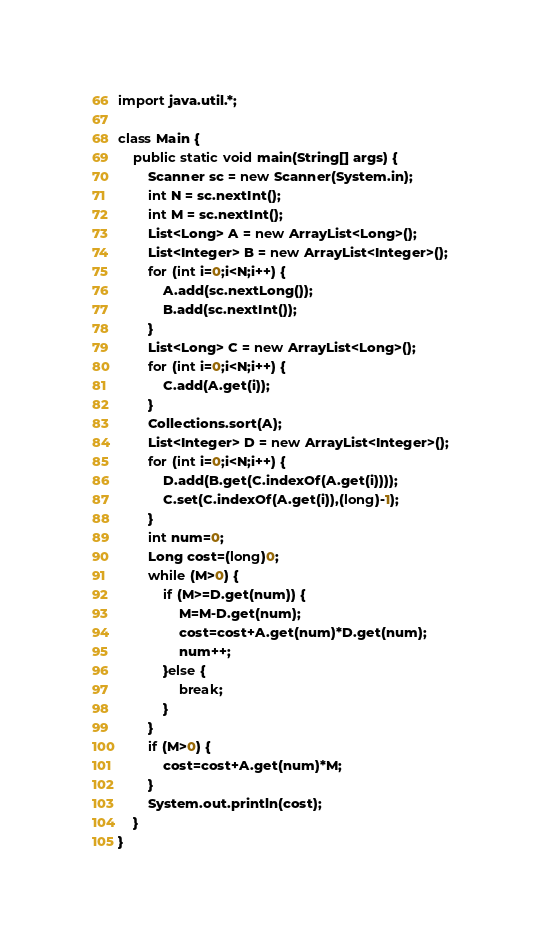Convert code to text. <code><loc_0><loc_0><loc_500><loc_500><_Java_>import java.util.*;

class Main {
	public static void main(String[] args) {
		Scanner sc = new Scanner(System.in);
		int N = sc.nextInt();
		int M = sc.nextInt();
		List<Long> A = new ArrayList<Long>();
		List<Integer> B = new ArrayList<Integer>();
		for (int i=0;i<N;i++) {
			A.add(sc.nextLong());
			B.add(sc.nextInt());
		}
		List<Long> C = new ArrayList<Long>();
		for (int i=0;i<N;i++) {
			C.add(A.get(i));
		}
		Collections.sort(A);
		List<Integer> D = new ArrayList<Integer>();
		for (int i=0;i<N;i++) {
			D.add(B.get(C.indexOf(A.get(i))));
			C.set(C.indexOf(A.get(i)),(long)-1);
		}
		int num=0;
		Long cost=(long)0;
		while (M>0) {
			if (M>=D.get(num)) {
				M=M-D.get(num);
				cost=cost+A.get(num)*D.get(num);
				num++;
			}else {
				break;
			}
		}
		if (M>0) {
			cost=cost+A.get(num)*M;
		}
		System.out.println(cost);
	}
}</code> 